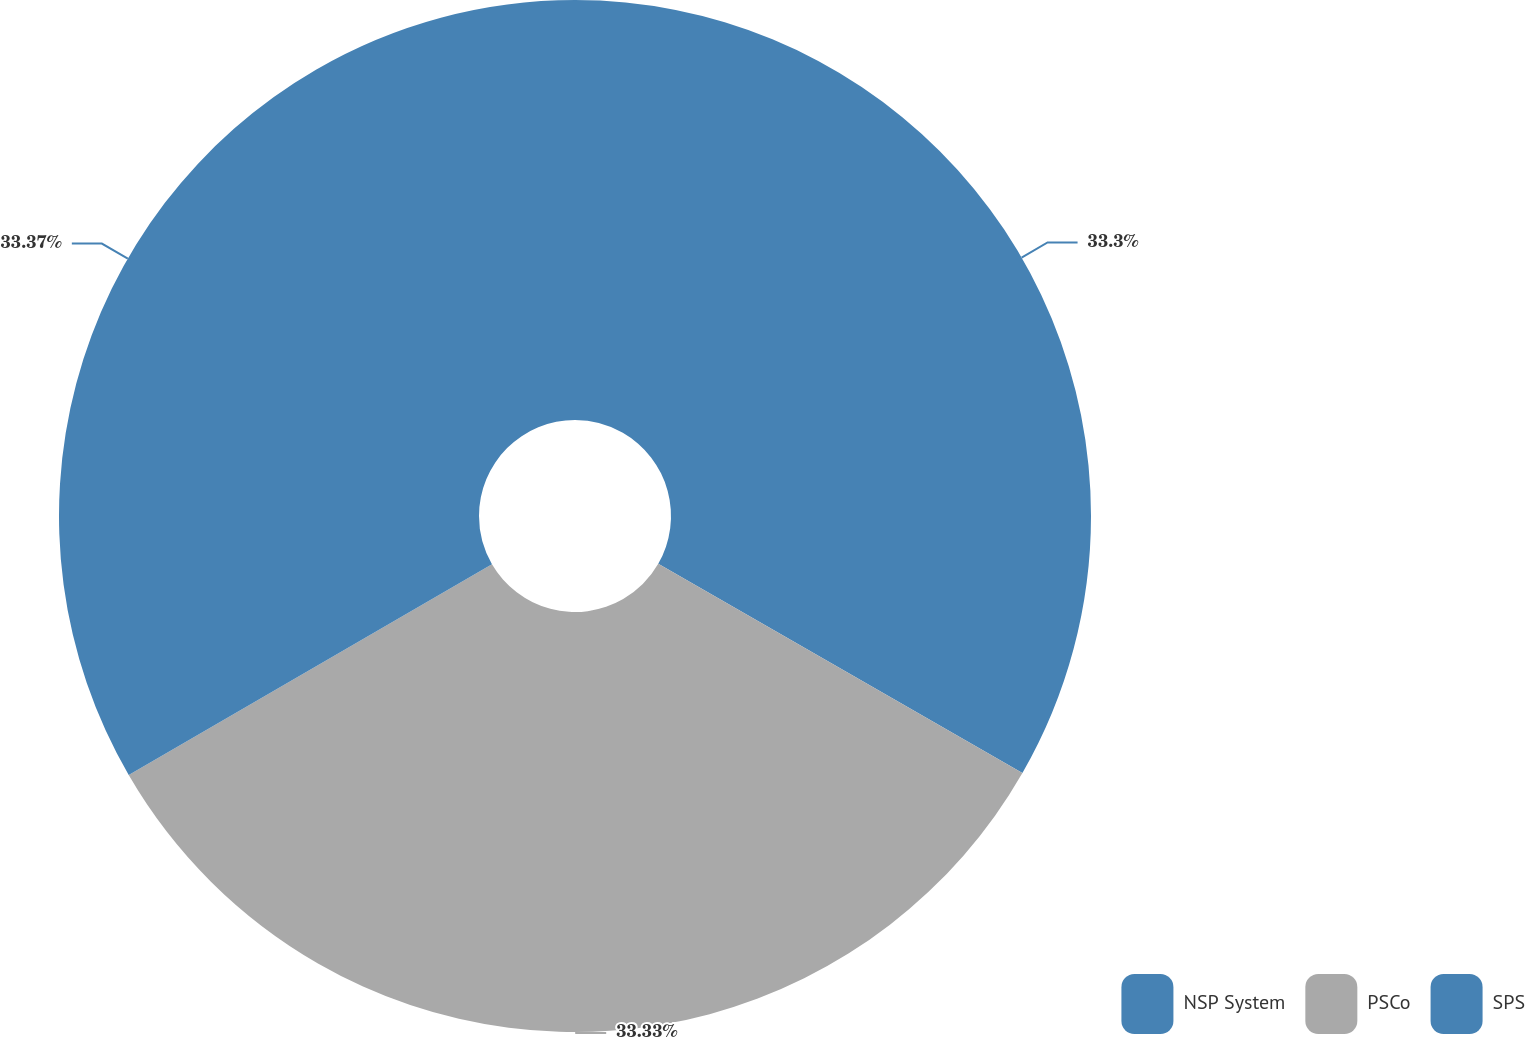Convert chart to OTSL. <chart><loc_0><loc_0><loc_500><loc_500><pie_chart><fcel>NSP System<fcel>PSCo<fcel>SPS<nl><fcel>33.3%<fcel>33.33%<fcel>33.37%<nl></chart> 